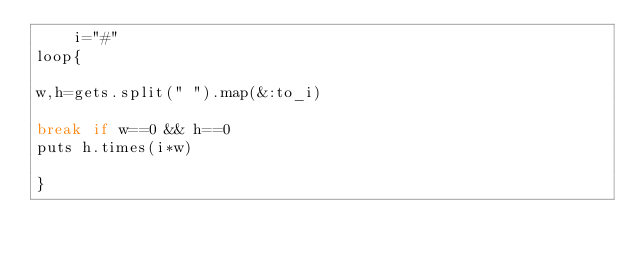Convert code to text. <code><loc_0><loc_0><loc_500><loc_500><_Ruby_>    i="#"
loop{

w,h=gets.split(" ").map(&:to_i)

break if w==0 && h==0
puts h.times(i*w)

}
</code> 